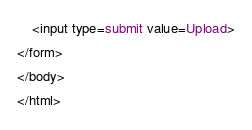<code> <loc_0><loc_0><loc_500><loc_500><_HTML_>    <input type=submit value=Upload>
</form>
</body>
</html></code> 